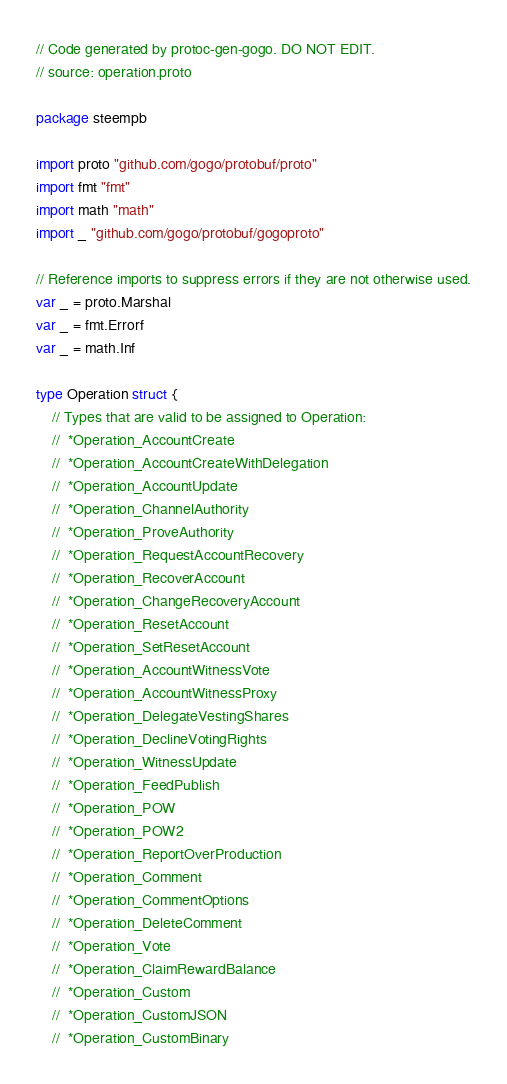<code> <loc_0><loc_0><loc_500><loc_500><_Go_>// Code generated by protoc-gen-gogo. DO NOT EDIT.
// source: operation.proto

package steempb

import proto "github.com/gogo/protobuf/proto"
import fmt "fmt"
import math "math"
import _ "github.com/gogo/protobuf/gogoproto"

// Reference imports to suppress errors if they are not otherwise used.
var _ = proto.Marshal
var _ = fmt.Errorf
var _ = math.Inf

type Operation struct {
	// Types that are valid to be assigned to Operation:
	//	*Operation_AccountCreate
	//	*Operation_AccountCreateWithDelegation
	//	*Operation_AccountUpdate
	//	*Operation_ChannelAuthority
	//	*Operation_ProveAuthority
	//	*Operation_RequestAccountRecovery
	//	*Operation_RecoverAccount
	//	*Operation_ChangeRecoveryAccount
	//	*Operation_ResetAccount
	//	*Operation_SetResetAccount
	//	*Operation_AccountWitnessVote
	//	*Operation_AccountWitnessProxy
	//	*Operation_DelegateVestingShares
	//	*Operation_DeclineVotingRights
	//	*Operation_WitnessUpdate
	//	*Operation_FeedPublish
	//	*Operation_POW
	//	*Operation_POW2
	//	*Operation_ReportOverProduction
	//	*Operation_Comment
	//	*Operation_CommentOptions
	//	*Operation_DeleteComment
	//	*Operation_Vote
	//	*Operation_ClaimRewardBalance
	//	*Operation_Custom
	//	*Operation_CustomJSON
	//	*Operation_CustomBinary</code> 